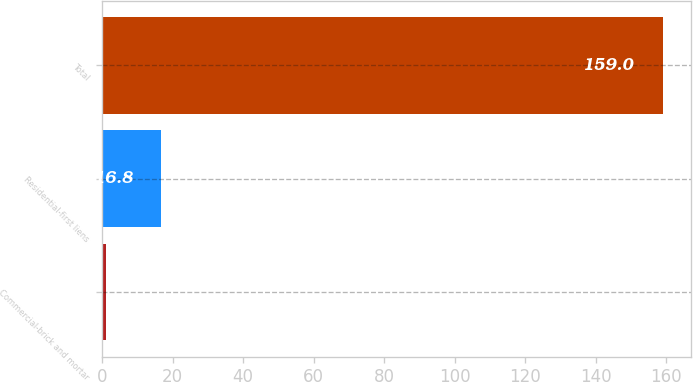Convert chart to OTSL. <chart><loc_0><loc_0><loc_500><loc_500><bar_chart><fcel>Commercial-brick and mortar<fcel>Residential-first liens<fcel>Total<nl><fcel>1<fcel>16.8<fcel>159<nl></chart> 